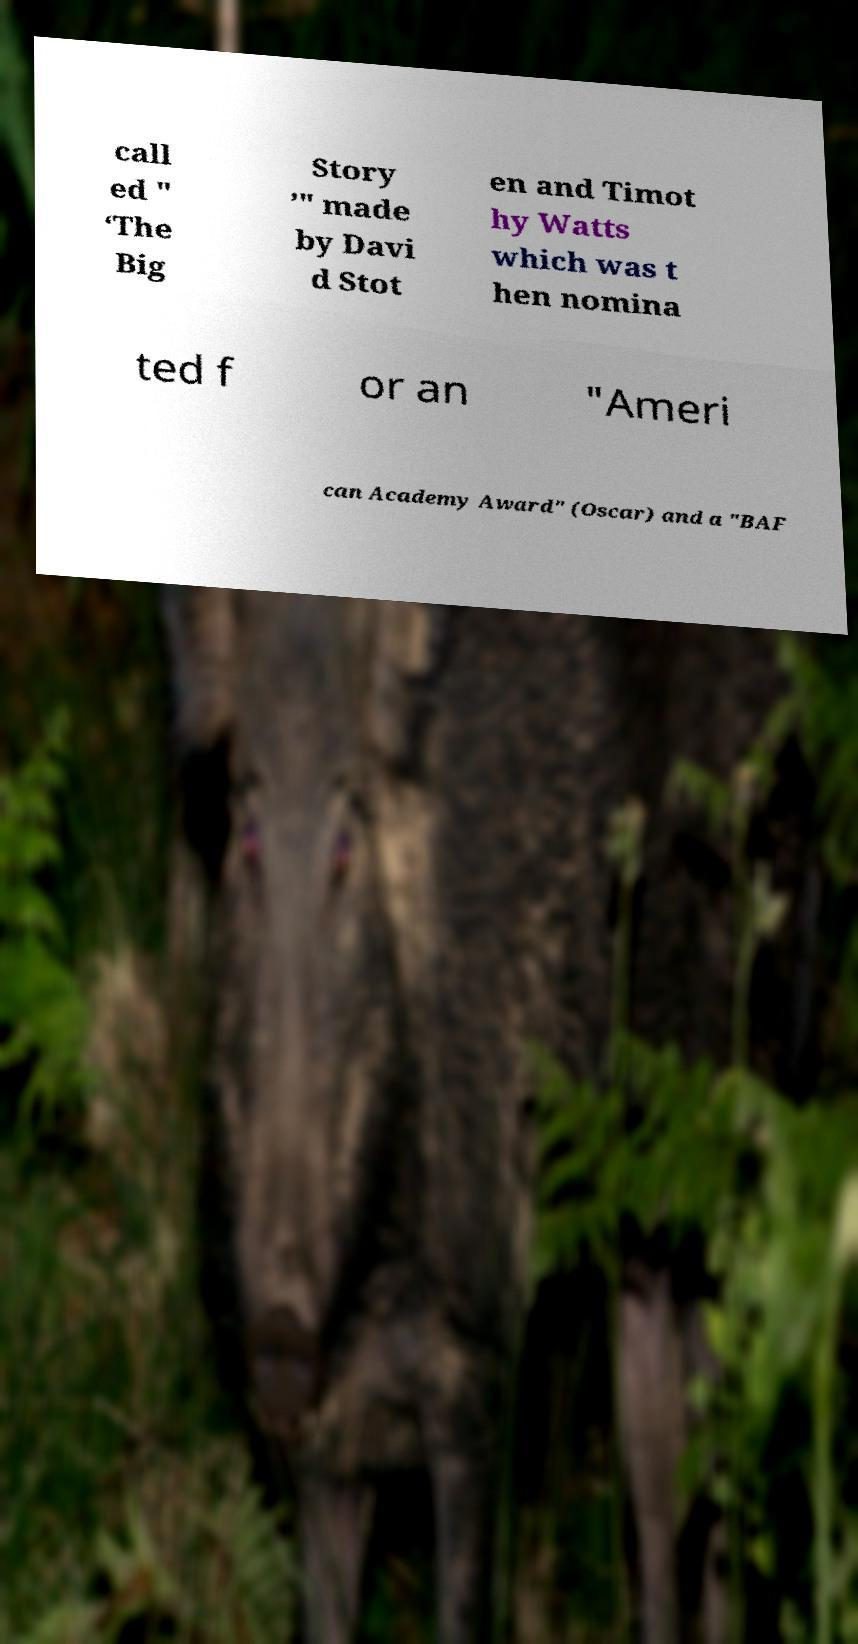For documentation purposes, I need the text within this image transcribed. Could you provide that? call ed " ‘The Big Story ’" made by Davi d Stot en and Timot hy Watts which was t hen nomina ted f or an "Ameri can Academy Award" (Oscar) and a "BAF 